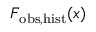<formula> <loc_0><loc_0><loc_500><loc_500>F _ { o b s , h i s t } ( x )</formula> 